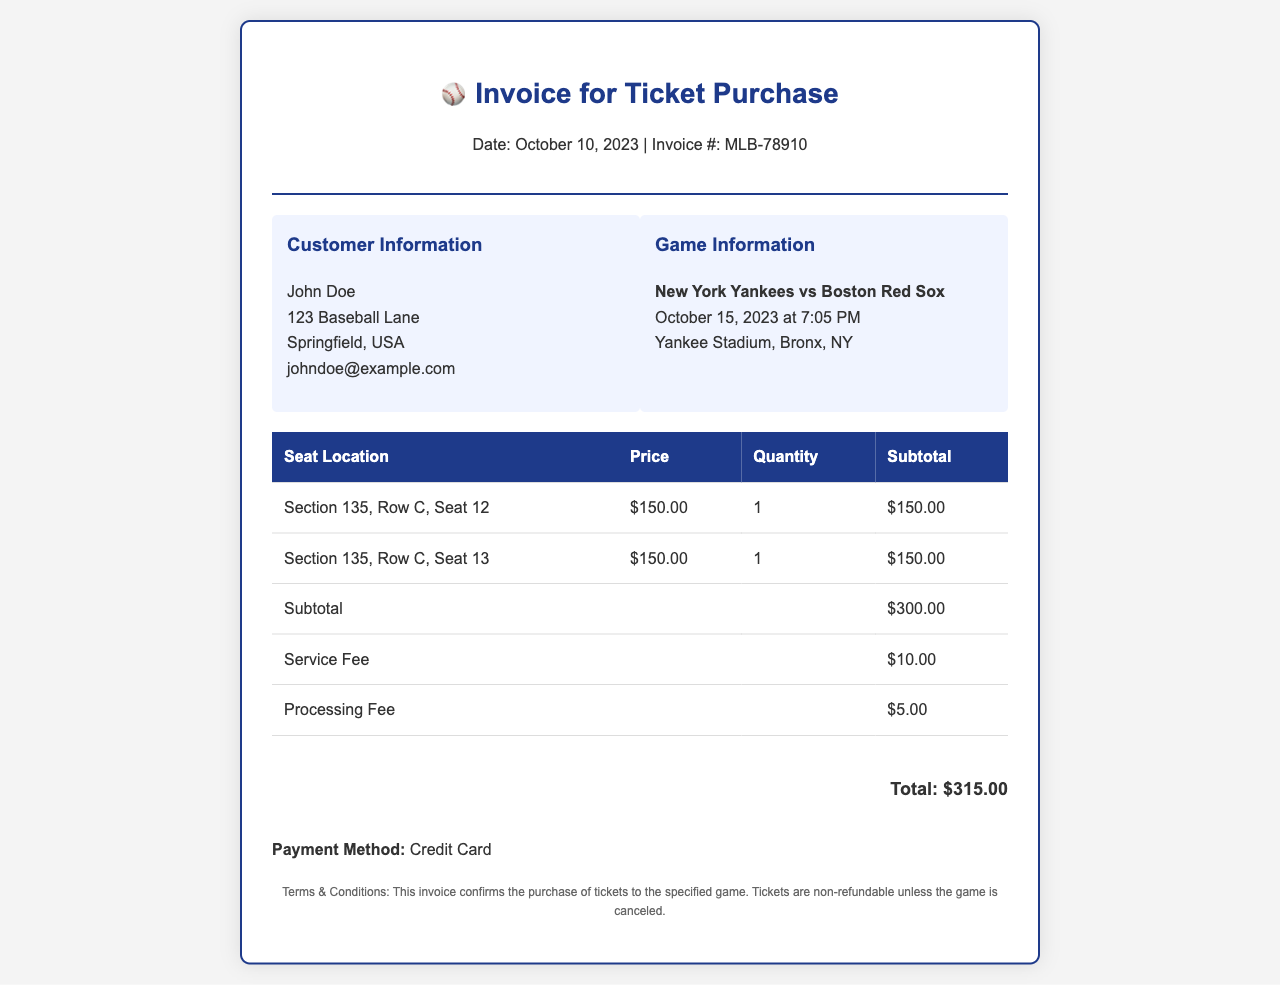What is the invoice date? The invoice date is a specific date mentioned in the document under the header section.
Answer: October 10, 2023 Who is the customer? The customer's name is provided in the customer information section of the document.
Answer: John Doe What is the subtotal amount? The subtotal amount is the total of all seat prices before any fees, listed at the bottom of the table.
Answer: $300.00 What is the processing fee? The processing fee is specified in the invoice table as an individual fee for the transaction.
Answer: $5.00 How many seats were purchased? The document indicates the quantity of seats purchased under the seat details.
Answer: 2 What is the total amount due? The total amount due is calculated by summing all amounts including fees, located at the bottom of the invoice.
Answer: $315.00 What is the payment method? The method of payment is explicitly stated in the invoice as part of the payment details.
Answer: Credit Card When is the game scheduled? The date and time of the game is provided in the game information section.
Answer: October 15, 2023 at 7:05 PM What is the seat location for the tickets? The seat locations are detailed in the table under the seat details section.
Answer: Section 135, Row C, Seat 12 and Section 135, Row C, Seat 13 